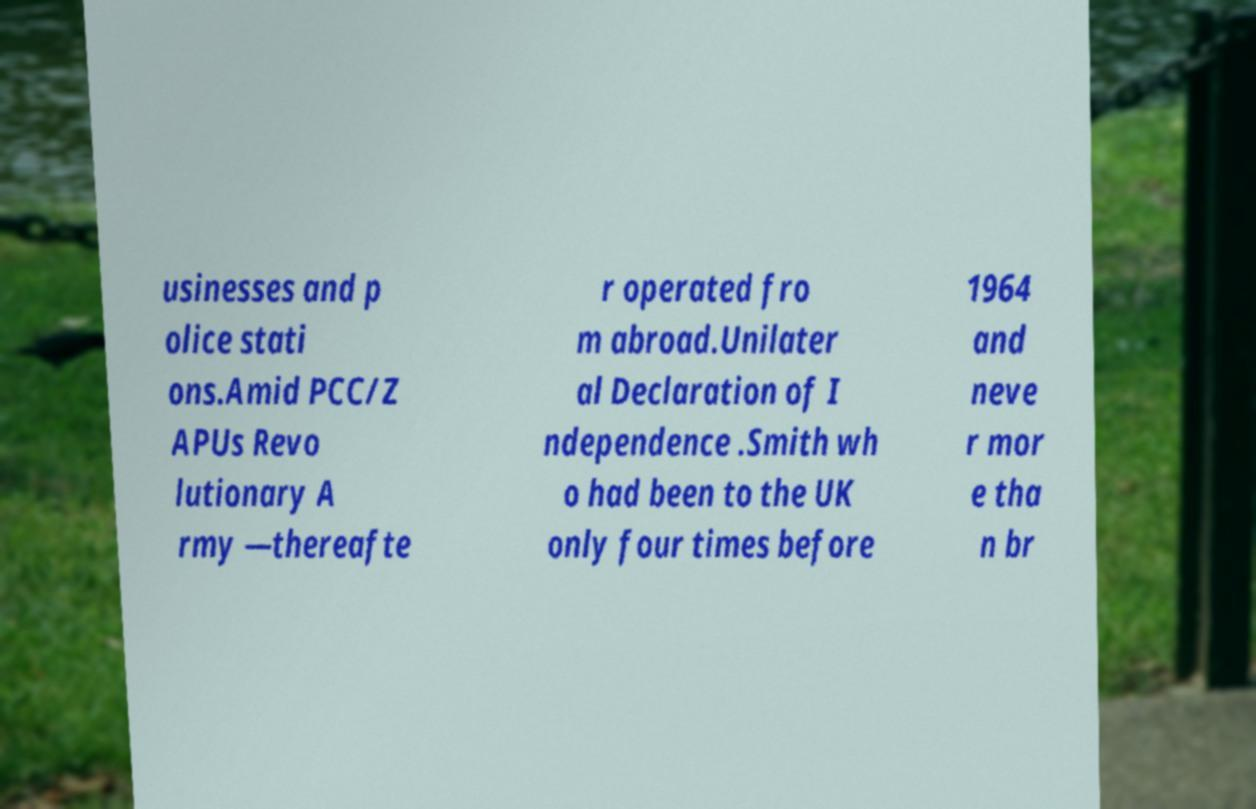What messages or text are displayed in this image? I need them in a readable, typed format. usinesses and p olice stati ons.Amid PCC/Z APUs Revo lutionary A rmy —thereafte r operated fro m abroad.Unilater al Declaration of I ndependence .Smith wh o had been to the UK only four times before 1964 and neve r mor e tha n br 